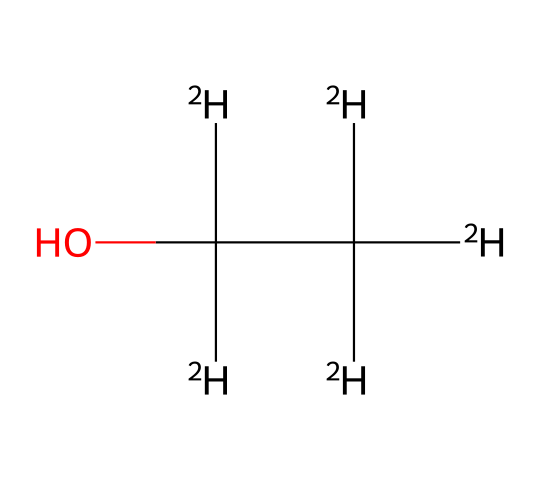how many hydrogen atoms are in this deuterated ethanol? The chemical structure shows that there are four distinct hydrogen atoms represented by the notation [2H]. In deuterated ethanol, each of the hydrogen atoms is replaced by the isotope deuterium, indicated by [2H].
Answer: four what type of alcohol is represented by this chemical structure? The structure illustrated shows a hydroxy group (-OH) attached to a carbon chain, which is characteristic of alcohols. Specifically, the presence of the hydroxy group on a two-carbon chain identifies it as ethanol.
Answer: ethanol how many carbon atoms are present in this molecule? The structure of the molecule demonstrates that there are two carbon atoms indicated by the two "C" labels in the SMILES representation. Each "C" corresponds to a carbon atom in the chain.
Answer: two what is the significance of using deuterated compounds in chemical applications? Deuterated compounds, such as this deuterated ethanol, are significant in chemical applications because they exhibit different physical properties compared to their non-deuterated counterparts. This can enhance their performance in certain contexts, such as in NMR spectroscopy and cleaning applications, where reduced noise and increased solvability are beneficial.
Answer: enhanced performance how does deuterated ethanol differ from regular ethanol in structure? In this chemical structure, deuterated ethanol replaces standard hydrogen atoms with deuterium atoms, as indicated by [2H]. This substitution alters the mass and some physical properties of the molecule while maintaining the same chemical functional group.
Answer: deuterium substitution what is the primary use of deuterated ethanol in audio equipment cleaning? Deuterated ethanol is primarily used in audio equipment cleaning due to its improved solvency and reduced volatility, which help prevent residue on sensitive components and enhance cleaning efficacy.
Answer: improved solvency 